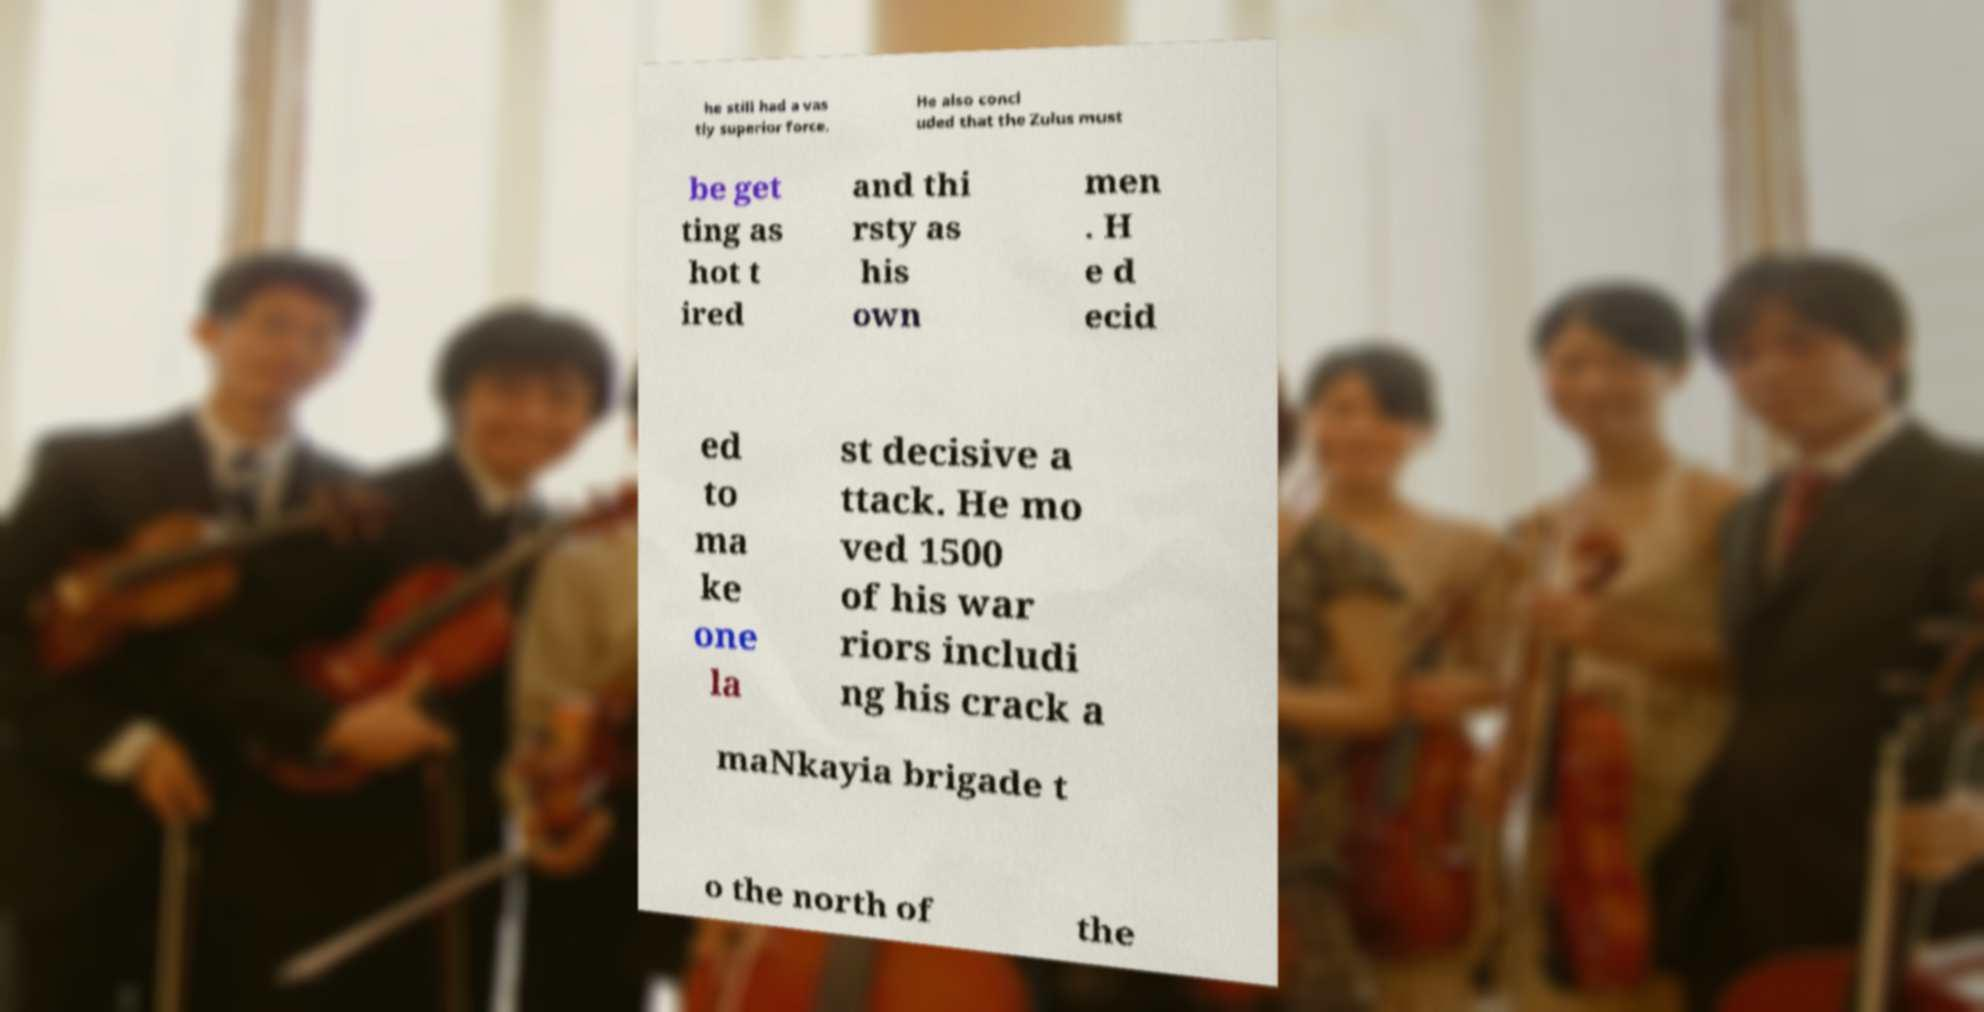For documentation purposes, I need the text within this image transcribed. Could you provide that? he still had a vas tly superior force. He also concl uded that the Zulus must be get ting as hot t ired and thi rsty as his own men . H e d ecid ed to ma ke one la st decisive a ttack. He mo ved 1500 of his war riors includi ng his crack a maNkayia brigade t o the north of the 